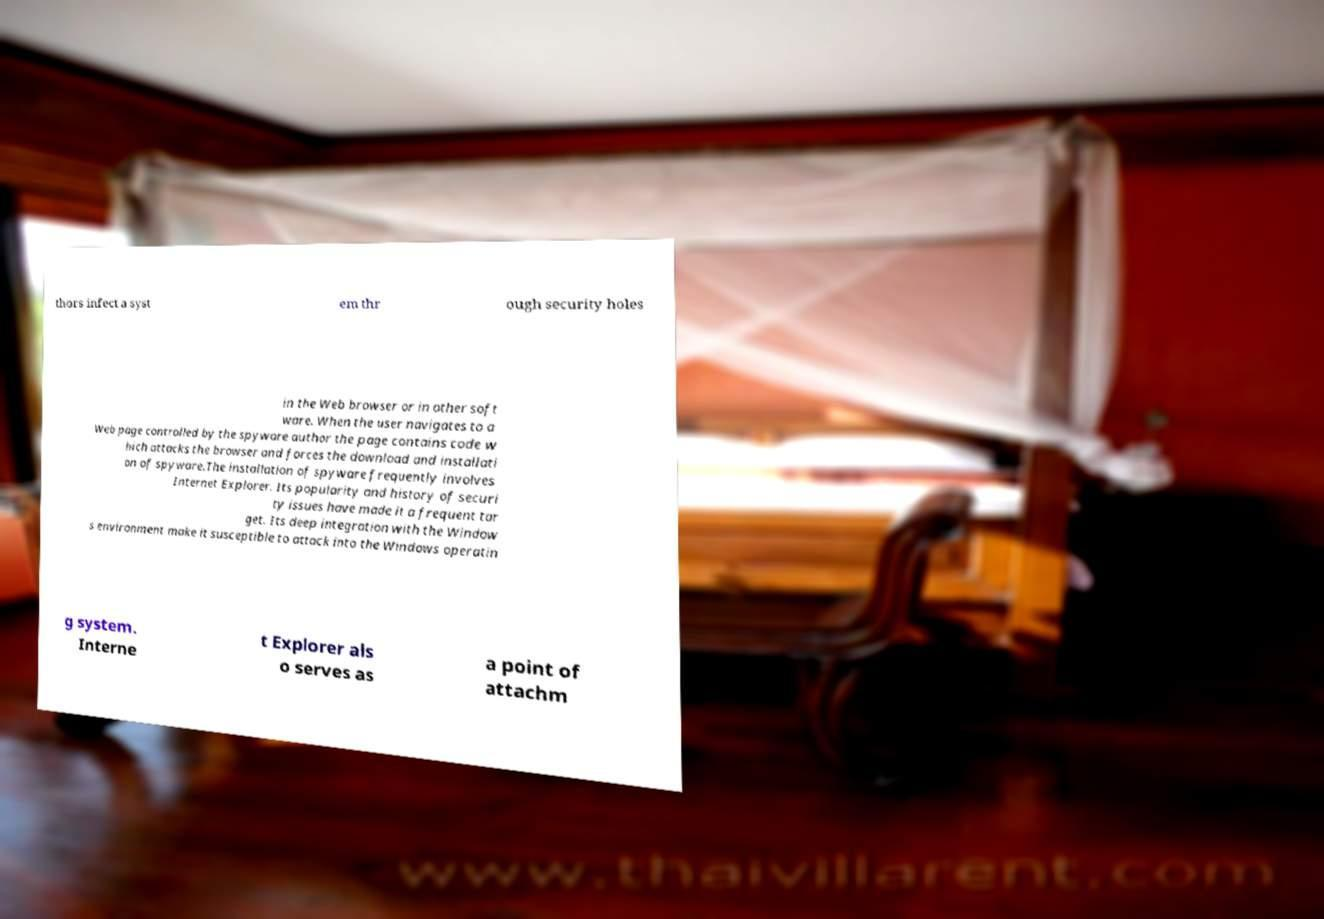I need the written content from this picture converted into text. Can you do that? thors infect a syst em thr ough security holes in the Web browser or in other soft ware. When the user navigates to a Web page controlled by the spyware author the page contains code w hich attacks the browser and forces the download and installati on of spyware.The installation of spyware frequently involves Internet Explorer. Its popularity and history of securi ty issues have made it a frequent tar get. Its deep integration with the Window s environment make it susceptible to attack into the Windows operatin g system. Interne t Explorer als o serves as a point of attachm 